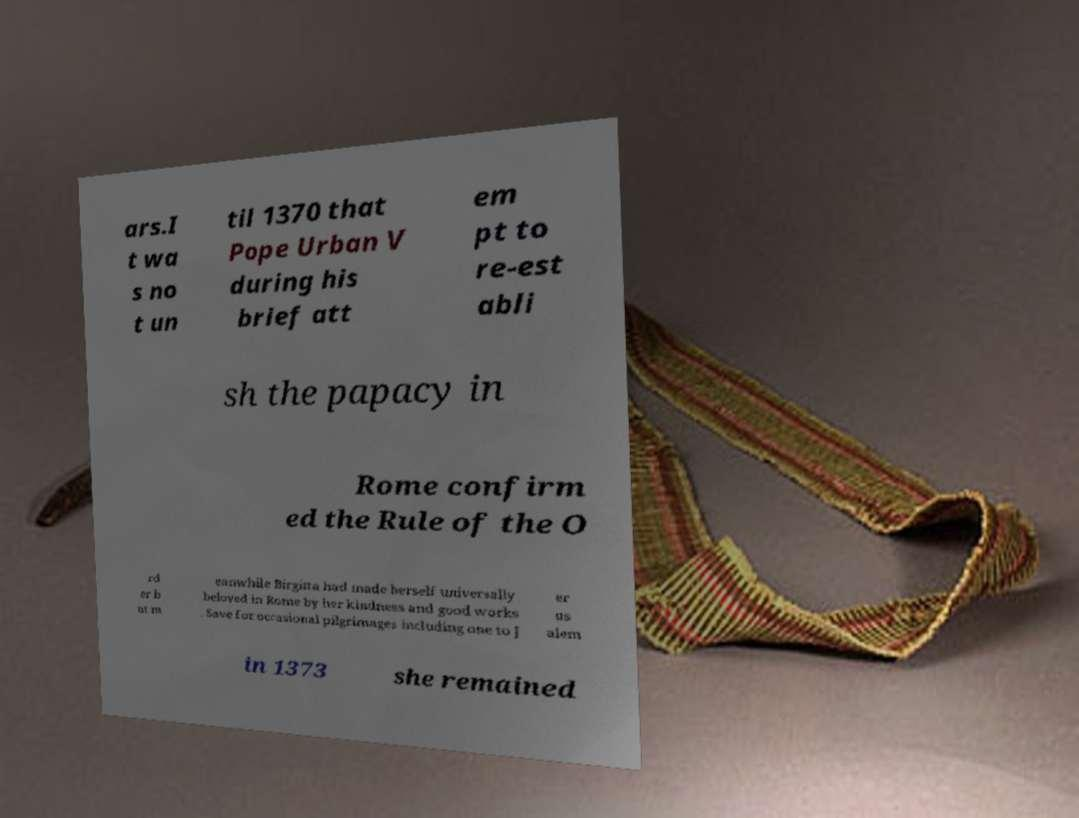Can you read and provide the text displayed in the image?This photo seems to have some interesting text. Can you extract and type it out for me? ars.I t wa s no t un til 1370 that Pope Urban V during his brief att em pt to re-est abli sh the papacy in Rome confirm ed the Rule of the O rd er b ut m eanwhile Birgitta had made herself universally beloved in Rome by her kindness and good works . Save for occasional pilgrimages including one to J er us alem in 1373 she remained 